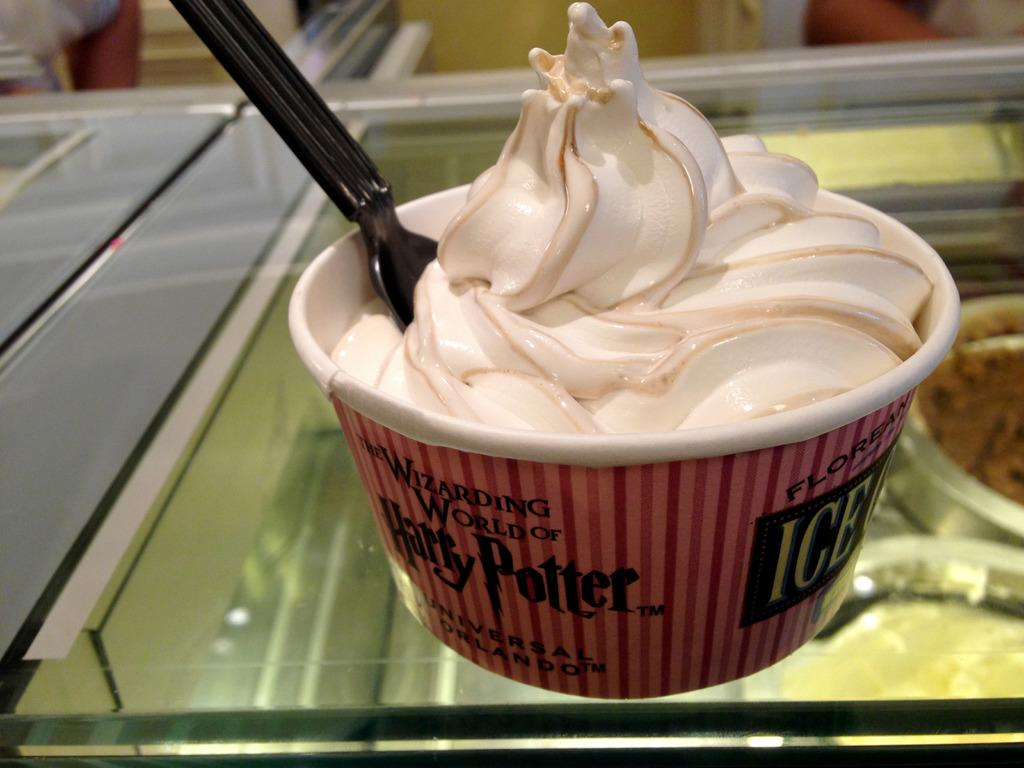What is present in the image that can hold a liquid? There is a glass in the image. What is placed on top of the glass? There is a cup on the glass. What is inside the cup? There is ice cream in the cup. What utensil is visible in the image? There is a spoon in the image. What type of land can be seen in the image? There is no land visible in the image; it features a glass, cup, ice cream, and a spoon. How many pages are present in the image? There are no pages visible in the image. 